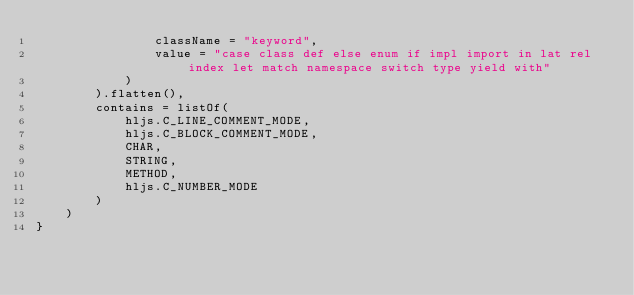<code> <loc_0><loc_0><loc_500><loc_500><_Kotlin_>                className = "keyword",
                value = "case class def else enum if impl import in lat rel index let match namespace switch type yield with"
            )
        ).flatten(),
        contains = listOf(
            hljs.C_LINE_COMMENT_MODE,
            hljs.C_BLOCK_COMMENT_MODE,
            CHAR,
            STRING,
            METHOD,
            hljs.C_NUMBER_MODE
        )
    )
}
</code> 